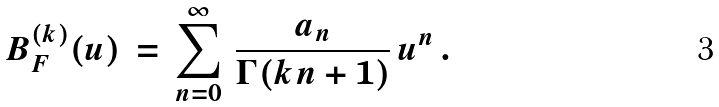Convert formula to latex. <formula><loc_0><loc_0><loc_500><loc_500>B ^ { ( k ) } _ { F } ( u ) \, = \, \sum _ { n = 0 } ^ { \infty } \, \frac { a _ { n } } { \Gamma ( k n + 1 ) } \, u ^ { n } \, .</formula> 